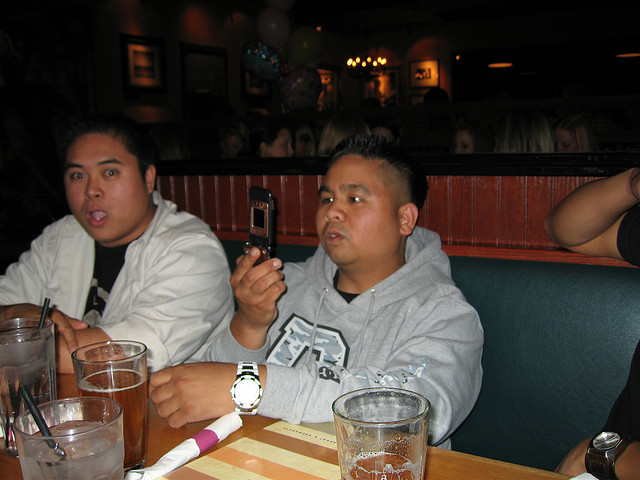<image>Is the phone likely newer than 2012? I don't know if the phone is newer than 2012. It could be either newer or older. Is the phone likely newer than 2012? I don't know if the phone is likely newer than 2012. It can be both newer or older. 